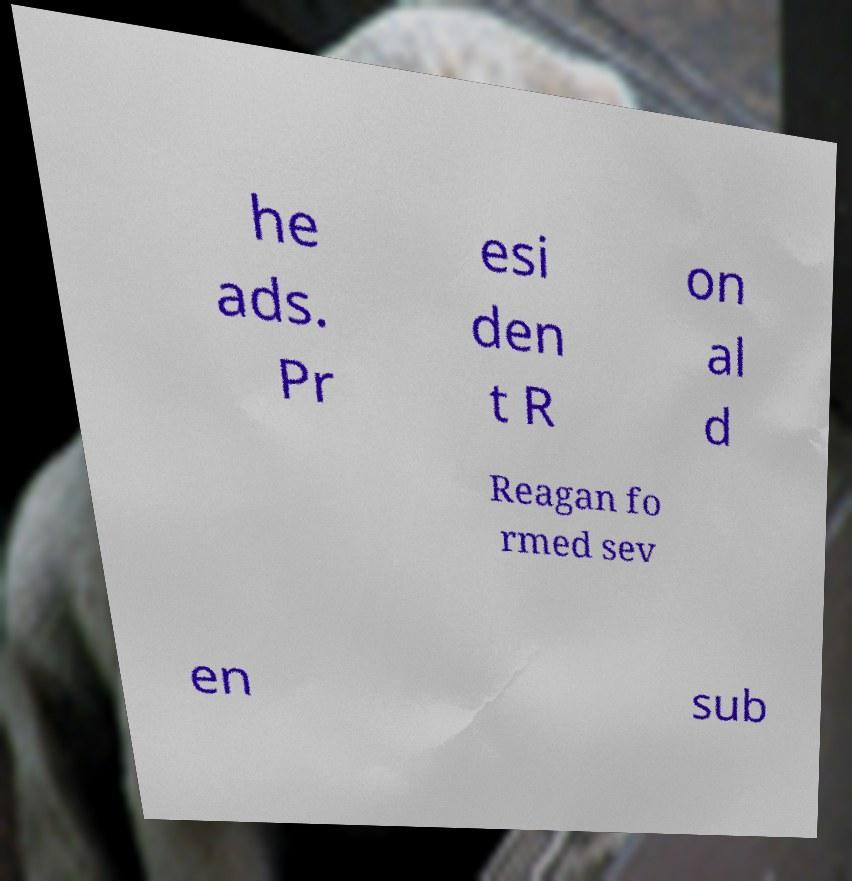Please read and relay the text visible in this image. What does it say? he ads. Pr esi den t R on al d Reagan fo rmed sev en sub 